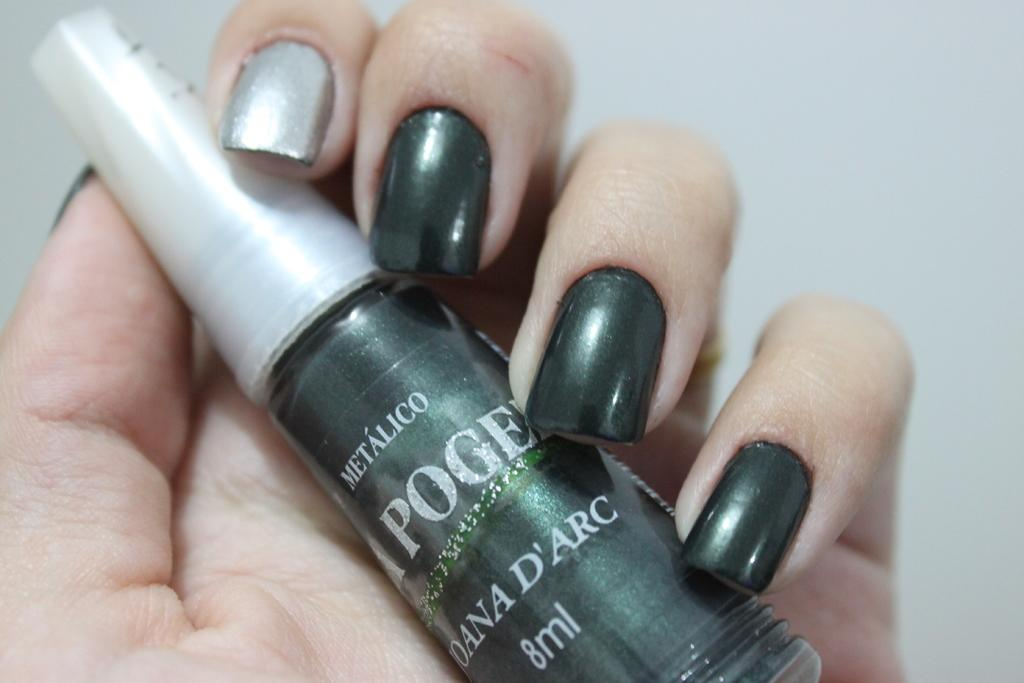<image>
Share a concise interpretation of the image provided. A woman is holding a bottle of Metalico l'apogee nail polish with the color in the bottle also on her nails. 